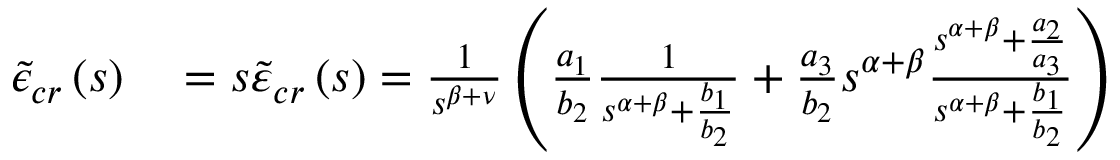<formula> <loc_0><loc_0><loc_500><loc_500>\begin{array} { r l } { \tilde { \epsilon } _ { c r } \left ( s \right ) } & = s \tilde { \varepsilon } _ { c r } \left ( s \right ) = \frac { 1 } { s ^ { \beta + \nu } } \left ( \frac { a _ { 1 } } { b _ { 2 } } \frac { 1 } { s ^ { \alpha + \beta } + \frac { b _ { 1 } } { b _ { 2 } } } + \frac { a _ { 3 } } { b _ { 2 } } s ^ { \alpha + \beta } \frac { s ^ { \alpha + \beta } + \frac { a _ { 2 } } { a _ { 3 } } } { s ^ { \alpha + \beta } + \frac { b _ { 1 } } { b _ { 2 } } } \right ) } \end{array}</formula> 